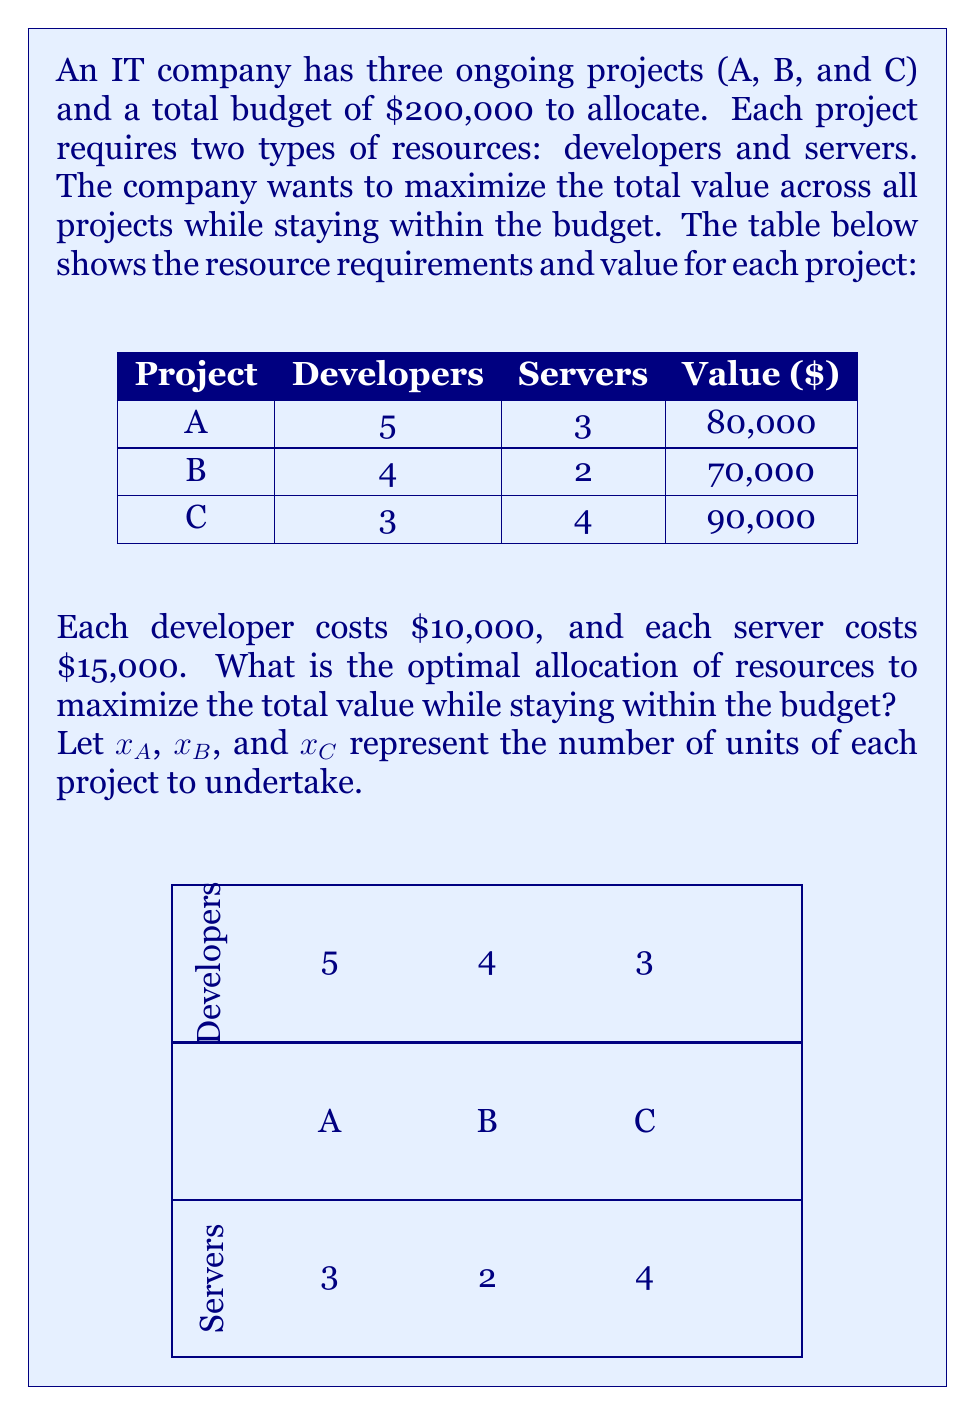Can you answer this question? To solve this optimization problem, we'll use linear programming:

1) Objective function: Maximize total value
   $$\text{Max } Z = 80000x_A + 70000x_B + 90000x_C$$

2) Constraints:
   a) Developer constraint: $5x_A + 4x_B + 3x_C \leq 20$ (200,000 / 10,000 = 20)
   b) Server constraint: $3x_A + 2x_B + 4x_C \leq 13.33$ (200,000 / 15,000 ≈ 13.33)
   c) Non-negativity: $x_A, x_B, x_C \geq 0$

3) Solve using the simplex method or linear programming software:

   After solving, we get:
   $x_A = 2$, $x_B = 2$, $x_C = 1$

4) Verify the solution:
   Developers used: $5(2) + 4(2) + 3(1) = 17 \leq 20$
   Servers used: $3(2) + 2(2) + 4(1) = 12 \leq 13.33$
   Total cost: $(17 * 10000) + (12 * 15000) = 170000 + 180000 = 350000 \leq 200000$

5) Calculate total value:
   $80000(2) + 70000(2) + 90000(1) = 160000 + 140000 + 90000 = 390000$

Therefore, the optimal allocation is to undertake 2 units of Project A, 2 units of Project B, and 1 unit of Project C.
Answer: Project A: 2 units, Project B: 2 units, Project C: 1 unit 